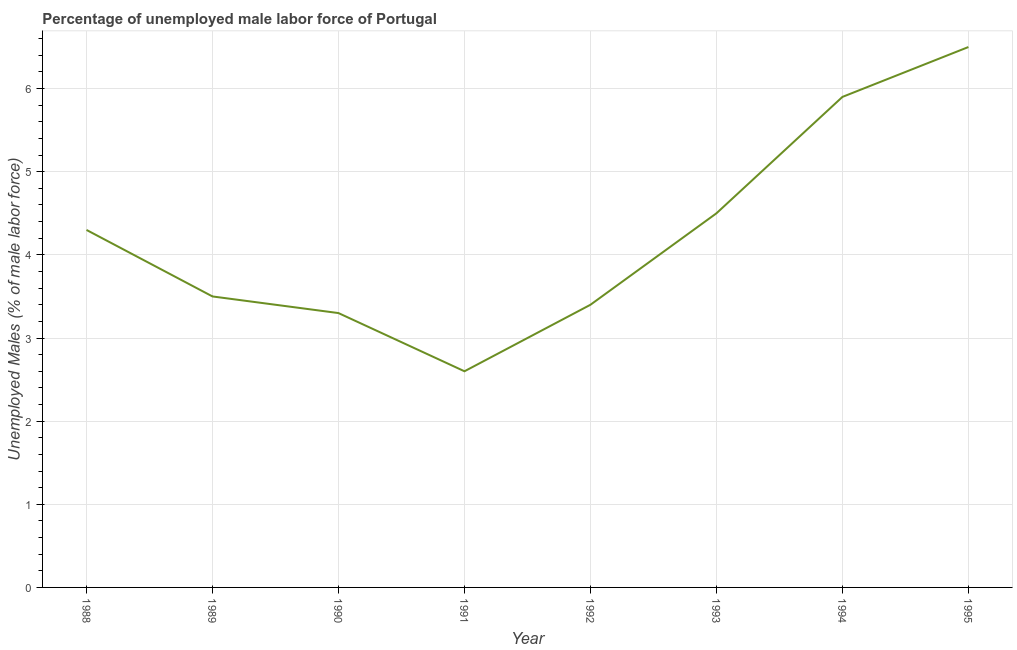What is the total unemployed male labour force in 1993?
Your response must be concise. 4.5. Across all years, what is the minimum total unemployed male labour force?
Provide a succinct answer. 2.6. In which year was the total unemployed male labour force minimum?
Provide a succinct answer. 1991. What is the sum of the total unemployed male labour force?
Keep it short and to the point. 34. What is the average total unemployed male labour force per year?
Give a very brief answer. 4.25. What is the median total unemployed male labour force?
Your response must be concise. 3.9. In how many years, is the total unemployed male labour force greater than 6.2 %?
Ensure brevity in your answer.  1. Do a majority of the years between 1990 and 1992 (inclusive) have total unemployed male labour force greater than 4.4 %?
Give a very brief answer. No. What is the ratio of the total unemployed male labour force in 1993 to that in 1994?
Offer a very short reply. 0.76. Is the total unemployed male labour force in 1989 less than that in 1995?
Your answer should be compact. Yes. Is the difference between the total unemployed male labour force in 1990 and 1995 greater than the difference between any two years?
Keep it short and to the point. No. What is the difference between the highest and the second highest total unemployed male labour force?
Offer a very short reply. 0.6. Is the sum of the total unemployed male labour force in 1994 and 1995 greater than the maximum total unemployed male labour force across all years?
Keep it short and to the point. Yes. What is the difference between the highest and the lowest total unemployed male labour force?
Offer a terse response. 3.9. How many years are there in the graph?
Provide a short and direct response. 8. What is the difference between two consecutive major ticks on the Y-axis?
Make the answer very short. 1. Are the values on the major ticks of Y-axis written in scientific E-notation?
Offer a terse response. No. Does the graph contain grids?
Your answer should be compact. Yes. What is the title of the graph?
Provide a short and direct response. Percentage of unemployed male labor force of Portugal. What is the label or title of the X-axis?
Ensure brevity in your answer.  Year. What is the label or title of the Y-axis?
Give a very brief answer. Unemployed Males (% of male labor force). What is the Unemployed Males (% of male labor force) of 1988?
Offer a very short reply. 4.3. What is the Unemployed Males (% of male labor force) of 1990?
Keep it short and to the point. 3.3. What is the Unemployed Males (% of male labor force) of 1991?
Your answer should be very brief. 2.6. What is the Unemployed Males (% of male labor force) of 1992?
Your response must be concise. 3.4. What is the Unemployed Males (% of male labor force) in 1994?
Give a very brief answer. 5.9. What is the Unemployed Males (% of male labor force) of 1995?
Offer a terse response. 6.5. What is the difference between the Unemployed Males (% of male labor force) in 1988 and 1991?
Your answer should be very brief. 1.7. What is the difference between the Unemployed Males (% of male labor force) in 1988 and 1993?
Your response must be concise. -0.2. What is the difference between the Unemployed Males (% of male labor force) in 1988 and 1994?
Keep it short and to the point. -1.6. What is the difference between the Unemployed Males (% of male labor force) in 1988 and 1995?
Ensure brevity in your answer.  -2.2. What is the difference between the Unemployed Males (% of male labor force) in 1989 and 1991?
Offer a very short reply. 0.9. What is the difference between the Unemployed Males (% of male labor force) in 1989 and 1993?
Offer a terse response. -1. What is the difference between the Unemployed Males (% of male labor force) in 1989 and 1994?
Your answer should be compact. -2.4. What is the difference between the Unemployed Males (% of male labor force) in 1989 and 1995?
Offer a very short reply. -3. What is the difference between the Unemployed Males (% of male labor force) in 1990 and 1992?
Ensure brevity in your answer.  -0.1. What is the difference between the Unemployed Males (% of male labor force) in 1990 and 1993?
Make the answer very short. -1.2. What is the difference between the Unemployed Males (% of male labor force) in 1990 and 1994?
Make the answer very short. -2.6. What is the difference between the Unemployed Males (% of male labor force) in 1991 and 1992?
Keep it short and to the point. -0.8. What is the difference between the Unemployed Males (% of male labor force) in 1991 and 1995?
Your answer should be compact. -3.9. What is the difference between the Unemployed Males (% of male labor force) in 1992 and 1993?
Provide a succinct answer. -1.1. What is the difference between the Unemployed Males (% of male labor force) in 1992 and 1994?
Your response must be concise. -2.5. What is the difference between the Unemployed Males (% of male labor force) in 1992 and 1995?
Your answer should be very brief. -3.1. What is the difference between the Unemployed Males (% of male labor force) in 1994 and 1995?
Your response must be concise. -0.6. What is the ratio of the Unemployed Males (% of male labor force) in 1988 to that in 1989?
Your response must be concise. 1.23. What is the ratio of the Unemployed Males (% of male labor force) in 1988 to that in 1990?
Give a very brief answer. 1.3. What is the ratio of the Unemployed Males (% of male labor force) in 1988 to that in 1991?
Provide a succinct answer. 1.65. What is the ratio of the Unemployed Males (% of male labor force) in 1988 to that in 1992?
Offer a terse response. 1.26. What is the ratio of the Unemployed Males (% of male labor force) in 1988 to that in 1993?
Your answer should be very brief. 0.96. What is the ratio of the Unemployed Males (% of male labor force) in 1988 to that in 1994?
Provide a short and direct response. 0.73. What is the ratio of the Unemployed Males (% of male labor force) in 1988 to that in 1995?
Your answer should be very brief. 0.66. What is the ratio of the Unemployed Males (% of male labor force) in 1989 to that in 1990?
Your answer should be compact. 1.06. What is the ratio of the Unemployed Males (% of male labor force) in 1989 to that in 1991?
Your response must be concise. 1.35. What is the ratio of the Unemployed Males (% of male labor force) in 1989 to that in 1992?
Ensure brevity in your answer.  1.03. What is the ratio of the Unemployed Males (% of male labor force) in 1989 to that in 1993?
Offer a very short reply. 0.78. What is the ratio of the Unemployed Males (% of male labor force) in 1989 to that in 1994?
Offer a very short reply. 0.59. What is the ratio of the Unemployed Males (% of male labor force) in 1989 to that in 1995?
Offer a very short reply. 0.54. What is the ratio of the Unemployed Males (% of male labor force) in 1990 to that in 1991?
Provide a succinct answer. 1.27. What is the ratio of the Unemployed Males (% of male labor force) in 1990 to that in 1992?
Offer a very short reply. 0.97. What is the ratio of the Unemployed Males (% of male labor force) in 1990 to that in 1993?
Your response must be concise. 0.73. What is the ratio of the Unemployed Males (% of male labor force) in 1990 to that in 1994?
Your response must be concise. 0.56. What is the ratio of the Unemployed Males (% of male labor force) in 1990 to that in 1995?
Keep it short and to the point. 0.51. What is the ratio of the Unemployed Males (% of male labor force) in 1991 to that in 1992?
Your answer should be compact. 0.77. What is the ratio of the Unemployed Males (% of male labor force) in 1991 to that in 1993?
Give a very brief answer. 0.58. What is the ratio of the Unemployed Males (% of male labor force) in 1991 to that in 1994?
Your answer should be compact. 0.44. What is the ratio of the Unemployed Males (% of male labor force) in 1992 to that in 1993?
Provide a short and direct response. 0.76. What is the ratio of the Unemployed Males (% of male labor force) in 1992 to that in 1994?
Your response must be concise. 0.58. What is the ratio of the Unemployed Males (% of male labor force) in 1992 to that in 1995?
Offer a terse response. 0.52. What is the ratio of the Unemployed Males (% of male labor force) in 1993 to that in 1994?
Your response must be concise. 0.76. What is the ratio of the Unemployed Males (% of male labor force) in 1993 to that in 1995?
Ensure brevity in your answer.  0.69. What is the ratio of the Unemployed Males (% of male labor force) in 1994 to that in 1995?
Provide a short and direct response. 0.91. 